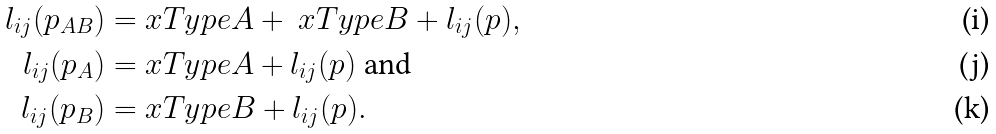<formula> <loc_0><loc_0><loc_500><loc_500>l _ { i j } ( p _ { A B } ) = & \ x T y p e { A } + \ x T y p e { B } + l _ { i j } ( p ) , \\ l _ { i j } ( p _ { A } ) = & \ x T y p e { A } + l _ { i j } ( p ) \text { and} \\ l _ { i j } ( p _ { B } ) = & \ x T y p e { B } + l _ { i j } ( p ) .</formula> 